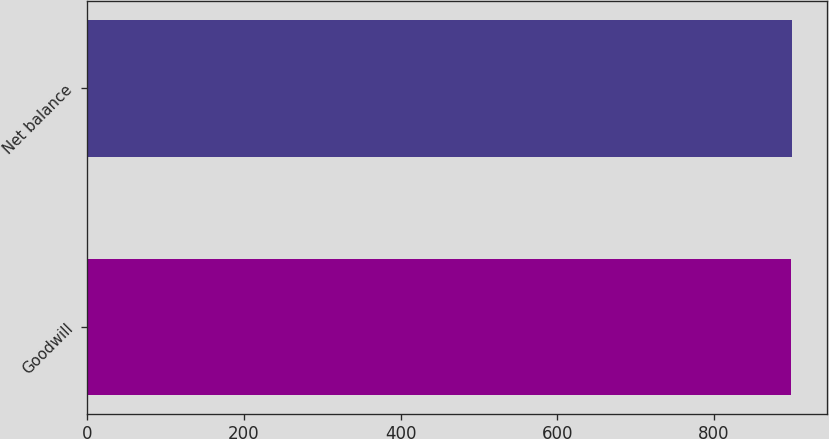<chart> <loc_0><loc_0><loc_500><loc_500><bar_chart><fcel>Goodwill<fcel>Net balance<nl><fcel>899<fcel>899.1<nl></chart> 